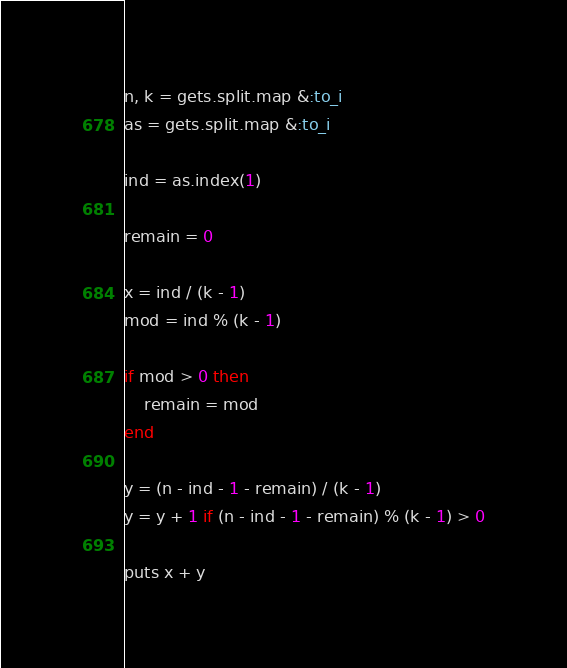<code> <loc_0><loc_0><loc_500><loc_500><_Ruby_>n, k = gets.split.map &:to_i
as = gets.split.map &:to_i

ind = as.index(1)

remain = 0

x = ind / (k - 1)
mod = ind % (k - 1)

if mod > 0 then
	remain = mod
end

y = (n - ind - 1 - remain) / (k - 1)
y = y + 1 if (n - ind - 1 - remain) % (k - 1) > 0

puts x + y
</code> 